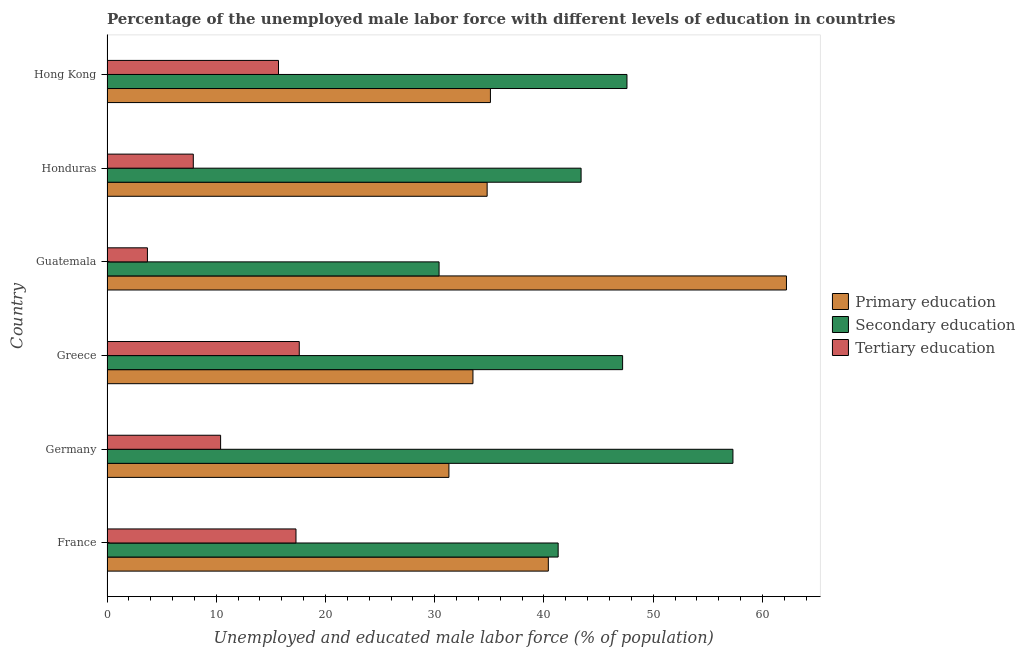How many groups of bars are there?
Give a very brief answer. 6. Are the number of bars per tick equal to the number of legend labels?
Your answer should be compact. Yes. Are the number of bars on each tick of the Y-axis equal?
Your answer should be very brief. Yes. How many bars are there on the 4th tick from the top?
Make the answer very short. 3. How many bars are there on the 3rd tick from the bottom?
Your response must be concise. 3. What is the label of the 6th group of bars from the top?
Give a very brief answer. France. In how many cases, is the number of bars for a given country not equal to the number of legend labels?
Offer a terse response. 0. What is the percentage of male labor force who received tertiary education in Honduras?
Keep it short and to the point. 7.9. Across all countries, what is the maximum percentage of male labor force who received primary education?
Provide a succinct answer. 62.2. Across all countries, what is the minimum percentage of male labor force who received secondary education?
Your answer should be very brief. 30.4. In which country was the percentage of male labor force who received secondary education maximum?
Offer a very short reply. Germany. In which country was the percentage of male labor force who received secondary education minimum?
Your answer should be compact. Guatemala. What is the total percentage of male labor force who received primary education in the graph?
Your response must be concise. 237.3. What is the difference between the percentage of male labor force who received tertiary education in Hong Kong and the percentage of male labor force who received secondary education in Germany?
Your answer should be very brief. -41.6. What is the average percentage of male labor force who received secondary education per country?
Give a very brief answer. 44.53. What is the difference between the percentage of male labor force who received secondary education and percentage of male labor force who received primary education in France?
Your answer should be very brief. 0.9. In how many countries, is the percentage of male labor force who received tertiary education greater than 48 %?
Provide a short and direct response. 0. What is the ratio of the percentage of male labor force who received primary education in France to that in Guatemala?
Your response must be concise. 0.65. Is the percentage of male labor force who received tertiary education in Guatemala less than that in Hong Kong?
Provide a succinct answer. Yes. Is the sum of the percentage of male labor force who received secondary education in Guatemala and Hong Kong greater than the maximum percentage of male labor force who received tertiary education across all countries?
Your response must be concise. Yes. What does the 1st bar from the top in Greece represents?
Provide a short and direct response. Tertiary education. What does the 1st bar from the bottom in Hong Kong represents?
Offer a very short reply. Primary education. Is it the case that in every country, the sum of the percentage of male labor force who received primary education and percentage of male labor force who received secondary education is greater than the percentage of male labor force who received tertiary education?
Offer a very short reply. Yes. Are all the bars in the graph horizontal?
Ensure brevity in your answer.  Yes. How many countries are there in the graph?
Provide a succinct answer. 6. What is the difference between two consecutive major ticks on the X-axis?
Provide a succinct answer. 10. Where does the legend appear in the graph?
Keep it short and to the point. Center right. How many legend labels are there?
Your answer should be compact. 3. What is the title of the graph?
Your answer should be compact. Percentage of the unemployed male labor force with different levels of education in countries. What is the label or title of the X-axis?
Provide a short and direct response. Unemployed and educated male labor force (% of population). What is the label or title of the Y-axis?
Provide a succinct answer. Country. What is the Unemployed and educated male labor force (% of population) in Primary education in France?
Make the answer very short. 40.4. What is the Unemployed and educated male labor force (% of population) of Secondary education in France?
Offer a terse response. 41.3. What is the Unemployed and educated male labor force (% of population) of Tertiary education in France?
Offer a terse response. 17.3. What is the Unemployed and educated male labor force (% of population) in Primary education in Germany?
Offer a very short reply. 31.3. What is the Unemployed and educated male labor force (% of population) in Secondary education in Germany?
Ensure brevity in your answer.  57.3. What is the Unemployed and educated male labor force (% of population) in Tertiary education in Germany?
Your answer should be compact. 10.4. What is the Unemployed and educated male labor force (% of population) of Primary education in Greece?
Offer a very short reply. 33.5. What is the Unemployed and educated male labor force (% of population) in Secondary education in Greece?
Give a very brief answer. 47.2. What is the Unemployed and educated male labor force (% of population) in Tertiary education in Greece?
Offer a terse response. 17.6. What is the Unemployed and educated male labor force (% of population) in Primary education in Guatemala?
Your response must be concise. 62.2. What is the Unemployed and educated male labor force (% of population) of Secondary education in Guatemala?
Make the answer very short. 30.4. What is the Unemployed and educated male labor force (% of population) in Tertiary education in Guatemala?
Your answer should be very brief. 3.7. What is the Unemployed and educated male labor force (% of population) of Primary education in Honduras?
Your answer should be compact. 34.8. What is the Unemployed and educated male labor force (% of population) of Secondary education in Honduras?
Your response must be concise. 43.4. What is the Unemployed and educated male labor force (% of population) of Tertiary education in Honduras?
Make the answer very short. 7.9. What is the Unemployed and educated male labor force (% of population) in Primary education in Hong Kong?
Provide a short and direct response. 35.1. What is the Unemployed and educated male labor force (% of population) of Secondary education in Hong Kong?
Keep it short and to the point. 47.6. What is the Unemployed and educated male labor force (% of population) of Tertiary education in Hong Kong?
Provide a succinct answer. 15.7. Across all countries, what is the maximum Unemployed and educated male labor force (% of population) of Primary education?
Your response must be concise. 62.2. Across all countries, what is the maximum Unemployed and educated male labor force (% of population) in Secondary education?
Your answer should be compact. 57.3. Across all countries, what is the maximum Unemployed and educated male labor force (% of population) in Tertiary education?
Ensure brevity in your answer.  17.6. Across all countries, what is the minimum Unemployed and educated male labor force (% of population) in Primary education?
Your response must be concise. 31.3. Across all countries, what is the minimum Unemployed and educated male labor force (% of population) of Secondary education?
Provide a short and direct response. 30.4. Across all countries, what is the minimum Unemployed and educated male labor force (% of population) of Tertiary education?
Ensure brevity in your answer.  3.7. What is the total Unemployed and educated male labor force (% of population) in Primary education in the graph?
Offer a terse response. 237.3. What is the total Unemployed and educated male labor force (% of population) in Secondary education in the graph?
Offer a very short reply. 267.2. What is the total Unemployed and educated male labor force (% of population) in Tertiary education in the graph?
Your answer should be very brief. 72.6. What is the difference between the Unemployed and educated male labor force (% of population) of Tertiary education in France and that in Germany?
Offer a very short reply. 6.9. What is the difference between the Unemployed and educated male labor force (% of population) of Primary education in France and that in Greece?
Make the answer very short. 6.9. What is the difference between the Unemployed and educated male labor force (% of population) in Secondary education in France and that in Greece?
Your answer should be very brief. -5.9. What is the difference between the Unemployed and educated male labor force (% of population) in Tertiary education in France and that in Greece?
Ensure brevity in your answer.  -0.3. What is the difference between the Unemployed and educated male labor force (% of population) of Primary education in France and that in Guatemala?
Give a very brief answer. -21.8. What is the difference between the Unemployed and educated male labor force (% of population) of Tertiary education in France and that in Guatemala?
Offer a terse response. 13.6. What is the difference between the Unemployed and educated male labor force (% of population) of Primary education in France and that in Honduras?
Your answer should be very brief. 5.6. What is the difference between the Unemployed and educated male labor force (% of population) of Secondary education in France and that in Honduras?
Offer a terse response. -2.1. What is the difference between the Unemployed and educated male labor force (% of population) of Secondary education in France and that in Hong Kong?
Provide a succinct answer. -6.3. What is the difference between the Unemployed and educated male labor force (% of population) in Tertiary education in France and that in Hong Kong?
Give a very brief answer. 1.6. What is the difference between the Unemployed and educated male labor force (% of population) in Primary education in Germany and that in Greece?
Provide a short and direct response. -2.2. What is the difference between the Unemployed and educated male labor force (% of population) in Primary education in Germany and that in Guatemala?
Give a very brief answer. -30.9. What is the difference between the Unemployed and educated male labor force (% of population) in Secondary education in Germany and that in Guatemala?
Ensure brevity in your answer.  26.9. What is the difference between the Unemployed and educated male labor force (% of population) in Secondary education in Germany and that in Honduras?
Provide a succinct answer. 13.9. What is the difference between the Unemployed and educated male labor force (% of population) of Primary education in Germany and that in Hong Kong?
Provide a succinct answer. -3.8. What is the difference between the Unemployed and educated male labor force (% of population) of Secondary education in Germany and that in Hong Kong?
Offer a terse response. 9.7. What is the difference between the Unemployed and educated male labor force (% of population) of Primary education in Greece and that in Guatemala?
Offer a very short reply. -28.7. What is the difference between the Unemployed and educated male labor force (% of population) of Tertiary education in Greece and that in Guatemala?
Give a very brief answer. 13.9. What is the difference between the Unemployed and educated male labor force (% of population) in Primary education in Greece and that in Honduras?
Offer a terse response. -1.3. What is the difference between the Unemployed and educated male labor force (% of population) of Secondary education in Greece and that in Honduras?
Offer a terse response. 3.8. What is the difference between the Unemployed and educated male labor force (% of population) of Tertiary education in Greece and that in Honduras?
Give a very brief answer. 9.7. What is the difference between the Unemployed and educated male labor force (% of population) in Primary education in Greece and that in Hong Kong?
Offer a very short reply. -1.6. What is the difference between the Unemployed and educated male labor force (% of population) in Secondary education in Greece and that in Hong Kong?
Your response must be concise. -0.4. What is the difference between the Unemployed and educated male labor force (% of population) of Primary education in Guatemala and that in Honduras?
Keep it short and to the point. 27.4. What is the difference between the Unemployed and educated male labor force (% of population) in Secondary education in Guatemala and that in Honduras?
Ensure brevity in your answer.  -13. What is the difference between the Unemployed and educated male labor force (% of population) in Primary education in Guatemala and that in Hong Kong?
Give a very brief answer. 27.1. What is the difference between the Unemployed and educated male labor force (% of population) in Secondary education in Guatemala and that in Hong Kong?
Your answer should be compact. -17.2. What is the difference between the Unemployed and educated male labor force (% of population) of Secondary education in Honduras and that in Hong Kong?
Ensure brevity in your answer.  -4.2. What is the difference between the Unemployed and educated male labor force (% of population) of Tertiary education in Honduras and that in Hong Kong?
Offer a terse response. -7.8. What is the difference between the Unemployed and educated male labor force (% of population) in Primary education in France and the Unemployed and educated male labor force (% of population) in Secondary education in Germany?
Make the answer very short. -16.9. What is the difference between the Unemployed and educated male labor force (% of population) in Primary education in France and the Unemployed and educated male labor force (% of population) in Tertiary education in Germany?
Make the answer very short. 30. What is the difference between the Unemployed and educated male labor force (% of population) of Secondary education in France and the Unemployed and educated male labor force (% of population) of Tertiary education in Germany?
Ensure brevity in your answer.  30.9. What is the difference between the Unemployed and educated male labor force (% of population) in Primary education in France and the Unemployed and educated male labor force (% of population) in Secondary education in Greece?
Provide a succinct answer. -6.8. What is the difference between the Unemployed and educated male labor force (% of population) of Primary education in France and the Unemployed and educated male labor force (% of population) of Tertiary education in Greece?
Your answer should be very brief. 22.8. What is the difference between the Unemployed and educated male labor force (% of population) of Secondary education in France and the Unemployed and educated male labor force (% of population) of Tertiary education in Greece?
Ensure brevity in your answer.  23.7. What is the difference between the Unemployed and educated male labor force (% of population) in Primary education in France and the Unemployed and educated male labor force (% of population) in Secondary education in Guatemala?
Your response must be concise. 10. What is the difference between the Unemployed and educated male labor force (% of population) in Primary education in France and the Unemployed and educated male labor force (% of population) in Tertiary education in Guatemala?
Your answer should be very brief. 36.7. What is the difference between the Unemployed and educated male labor force (% of population) in Secondary education in France and the Unemployed and educated male labor force (% of population) in Tertiary education in Guatemala?
Ensure brevity in your answer.  37.6. What is the difference between the Unemployed and educated male labor force (% of population) of Primary education in France and the Unemployed and educated male labor force (% of population) of Tertiary education in Honduras?
Your answer should be compact. 32.5. What is the difference between the Unemployed and educated male labor force (% of population) of Secondary education in France and the Unemployed and educated male labor force (% of population) of Tertiary education in Honduras?
Your response must be concise. 33.4. What is the difference between the Unemployed and educated male labor force (% of population) of Primary education in France and the Unemployed and educated male labor force (% of population) of Secondary education in Hong Kong?
Make the answer very short. -7.2. What is the difference between the Unemployed and educated male labor force (% of population) in Primary education in France and the Unemployed and educated male labor force (% of population) in Tertiary education in Hong Kong?
Ensure brevity in your answer.  24.7. What is the difference between the Unemployed and educated male labor force (% of population) of Secondary education in France and the Unemployed and educated male labor force (% of population) of Tertiary education in Hong Kong?
Make the answer very short. 25.6. What is the difference between the Unemployed and educated male labor force (% of population) in Primary education in Germany and the Unemployed and educated male labor force (% of population) in Secondary education in Greece?
Provide a short and direct response. -15.9. What is the difference between the Unemployed and educated male labor force (% of population) in Primary education in Germany and the Unemployed and educated male labor force (% of population) in Tertiary education in Greece?
Provide a short and direct response. 13.7. What is the difference between the Unemployed and educated male labor force (% of population) in Secondary education in Germany and the Unemployed and educated male labor force (% of population) in Tertiary education in Greece?
Your answer should be very brief. 39.7. What is the difference between the Unemployed and educated male labor force (% of population) in Primary education in Germany and the Unemployed and educated male labor force (% of population) in Secondary education in Guatemala?
Your answer should be compact. 0.9. What is the difference between the Unemployed and educated male labor force (% of population) of Primary education in Germany and the Unemployed and educated male labor force (% of population) of Tertiary education in Guatemala?
Offer a very short reply. 27.6. What is the difference between the Unemployed and educated male labor force (% of population) of Secondary education in Germany and the Unemployed and educated male labor force (% of population) of Tertiary education in Guatemala?
Keep it short and to the point. 53.6. What is the difference between the Unemployed and educated male labor force (% of population) of Primary education in Germany and the Unemployed and educated male labor force (% of population) of Secondary education in Honduras?
Offer a very short reply. -12.1. What is the difference between the Unemployed and educated male labor force (% of population) of Primary education in Germany and the Unemployed and educated male labor force (% of population) of Tertiary education in Honduras?
Your response must be concise. 23.4. What is the difference between the Unemployed and educated male labor force (% of population) in Secondary education in Germany and the Unemployed and educated male labor force (% of population) in Tertiary education in Honduras?
Offer a very short reply. 49.4. What is the difference between the Unemployed and educated male labor force (% of population) in Primary education in Germany and the Unemployed and educated male labor force (% of population) in Secondary education in Hong Kong?
Your answer should be very brief. -16.3. What is the difference between the Unemployed and educated male labor force (% of population) in Secondary education in Germany and the Unemployed and educated male labor force (% of population) in Tertiary education in Hong Kong?
Provide a short and direct response. 41.6. What is the difference between the Unemployed and educated male labor force (% of population) in Primary education in Greece and the Unemployed and educated male labor force (% of population) in Secondary education in Guatemala?
Provide a succinct answer. 3.1. What is the difference between the Unemployed and educated male labor force (% of population) of Primary education in Greece and the Unemployed and educated male labor force (% of population) of Tertiary education in Guatemala?
Offer a very short reply. 29.8. What is the difference between the Unemployed and educated male labor force (% of population) of Secondary education in Greece and the Unemployed and educated male labor force (% of population) of Tertiary education in Guatemala?
Make the answer very short. 43.5. What is the difference between the Unemployed and educated male labor force (% of population) of Primary education in Greece and the Unemployed and educated male labor force (% of population) of Secondary education in Honduras?
Provide a short and direct response. -9.9. What is the difference between the Unemployed and educated male labor force (% of population) of Primary education in Greece and the Unemployed and educated male labor force (% of population) of Tertiary education in Honduras?
Provide a succinct answer. 25.6. What is the difference between the Unemployed and educated male labor force (% of population) of Secondary education in Greece and the Unemployed and educated male labor force (% of population) of Tertiary education in Honduras?
Your answer should be very brief. 39.3. What is the difference between the Unemployed and educated male labor force (% of population) of Primary education in Greece and the Unemployed and educated male labor force (% of population) of Secondary education in Hong Kong?
Your response must be concise. -14.1. What is the difference between the Unemployed and educated male labor force (% of population) in Secondary education in Greece and the Unemployed and educated male labor force (% of population) in Tertiary education in Hong Kong?
Give a very brief answer. 31.5. What is the difference between the Unemployed and educated male labor force (% of population) of Primary education in Guatemala and the Unemployed and educated male labor force (% of population) of Secondary education in Honduras?
Provide a succinct answer. 18.8. What is the difference between the Unemployed and educated male labor force (% of population) of Primary education in Guatemala and the Unemployed and educated male labor force (% of population) of Tertiary education in Honduras?
Keep it short and to the point. 54.3. What is the difference between the Unemployed and educated male labor force (% of population) in Secondary education in Guatemala and the Unemployed and educated male labor force (% of population) in Tertiary education in Honduras?
Provide a succinct answer. 22.5. What is the difference between the Unemployed and educated male labor force (% of population) of Primary education in Guatemala and the Unemployed and educated male labor force (% of population) of Secondary education in Hong Kong?
Provide a succinct answer. 14.6. What is the difference between the Unemployed and educated male labor force (% of population) in Primary education in Guatemala and the Unemployed and educated male labor force (% of population) in Tertiary education in Hong Kong?
Keep it short and to the point. 46.5. What is the difference between the Unemployed and educated male labor force (% of population) of Secondary education in Guatemala and the Unemployed and educated male labor force (% of population) of Tertiary education in Hong Kong?
Offer a very short reply. 14.7. What is the difference between the Unemployed and educated male labor force (% of population) of Secondary education in Honduras and the Unemployed and educated male labor force (% of population) of Tertiary education in Hong Kong?
Offer a terse response. 27.7. What is the average Unemployed and educated male labor force (% of population) of Primary education per country?
Your answer should be compact. 39.55. What is the average Unemployed and educated male labor force (% of population) in Secondary education per country?
Keep it short and to the point. 44.53. What is the difference between the Unemployed and educated male labor force (% of population) of Primary education and Unemployed and educated male labor force (% of population) of Tertiary education in France?
Your answer should be very brief. 23.1. What is the difference between the Unemployed and educated male labor force (% of population) in Secondary education and Unemployed and educated male labor force (% of population) in Tertiary education in France?
Your response must be concise. 24. What is the difference between the Unemployed and educated male labor force (% of population) in Primary education and Unemployed and educated male labor force (% of population) in Secondary education in Germany?
Your response must be concise. -26. What is the difference between the Unemployed and educated male labor force (% of population) in Primary education and Unemployed and educated male labor force (% of population) in Tertiary education in Germany?
Provide a succinct answer. 20.9. What is the difference between the Unemployed and educated male labor force (% of population) in Secondary education and Unemployed and educated male labor force (% of population) in Tertiary education in Germany?
Give a very brief answer. 46.9. What is the difference between the Unemployed and educated male labor force (% of population) in Primary education and Unemployed and educated male labor force (% of population) in Secondary education in Greece?
Your response must be concise. -13.7. What is the difference between the Unemployed and educated male labor force (% of population) in Secondary education and Unemployed and educated male labor force (% of population) in Tertiary education in Greece?
Keep it short and to the point. 29.6. What is the difference between the Unemployed and educated male labor force (% of population) in Primary education and Unemployed and educated male labor force (% of population) in Secondary education in Guatemala?
Offer a terse response. 31.8. What is the difference between the Unemployed and educated male labor force (% of population) of Primary education and Unemployed and educated male labor force (% of population) of Tertiary education in Guatemala?
Your response must be concise. 58.5. What is the difference between the Unemployed and educated male labor force (% of population) of Secondary education and Unemployed and educated male labor force (% of population) of Tertiary education in Guatemala?
Give a very brief answer. 26.7. What is the difference between the Unemployed and educated male labor force (% of population) in Primary education and Unemployed and educated male labor force (% of population) in Tertiary education in Honduras?
Offer a terse response. 26.9. What is the difference between the Unemployed and educated male labor force (% of population) in Secondary education and Unemployed and educated male labor force (% of population) in Tertiary education in Honduras?
Keep it short and to the point. 35.5. What is the difference between the Unemployed and educated male labor force (% of population) of Primary education and Unemployed and educated male labor force (% of population) of Tertiary education in Hong Kong?
Offer a terse response. 19.4. What is the difference between the Unemployed and educated male labor force (% of population) in Secondary education and Unemployed and educated male labor force (% of population) in Tertiary education in Hong Kong?
Your answer should be compact. 31.9. What is the ratio of the Unemployed and educated male labor force (% of population) of Primary education in France to that in Germany?
Provide a succinct answer. 1.29. What is the ratio of the Unemployed and educated male labor force (% of population) of Secondary education in France to that in Germany?
Your answer should be compact. 0.72. What is the ratio of the Unemployed and educated male labor force (% of population) of Tertiary education in France to that in Germany?
Ensure brevity in your answer.  1.66. What is the ratio of the Unemployed and educated male labor force (% of population) of Primary education in France to that in Greece?
Make the answer very short. 1.21. What is the ratio of the Unemployed and educated male labor force (% of population) of Primary education in France to that in Guatemala?
Ensure brevity in your answer.  0.65. What is the ratio of the Unemployed and educated male labor force (% of population) in Secondary education in France to that in Guatemala?
Offer a very short reply. 1.36. What is the ratio of the Unemployed and educated male labor force (% of population) in Tertiary education in France to that in Guatemala?
Make the answer very short. 4.68. What is the ratio of the Unemployed and educated male labor force (% of population) of Primary education in France to that in Honduras?
Make the answer very short. 1.16. What is the ratio of the Unemployed and educated male labor force (% of population) of Secondary education in France to that in Honduras?
Offer a very short reply. 0.95. What is the ratio of the Unemployed and educated male labor force (% of population) of Tertiary education in France to that in Honduras?
Your response must be concise. 2.19. What is the ratio of the Unemployed and educated male labor force (% of population) of Primary education in France to that in Hong Kong?
Provide a short and direct response. 1.15. What is the ratio of the Unemployed and educated male labor force (% of population) in Secondary education in France to that in Hong Kong?
Your answer should be compact. 0.87. What is the ratio of the Unemployed and educated male labor force (% of population) in Tertiary education in France to that in Hong Kong?
Provide a short and direct response. 1.1. What is the ratio of the Unemployed and educated male labor force (% of population) of Primary education in Germany to that in Greece?
Keep it short and to the point. 0.93. What is the ratio of the Unemployed and educated male labor force (% of population) in Secondary education in Germany to that in Greece?
Make the answer very short. 1.21. What is the ratio of the Unemployed and educated male labor force (% of population) in Tertiary education in Germany to that in Greece?
Make the answer very short. 0.59. What is the ratio of the Unemployed and educated male labor force (% of population) in Primary education in Germany to that in Guatemala?
Provide a succinct answer. 0.5. What is the ratio of the Unemployed and educated male labor force (% of population) of Secondary education in Germany to that in Guatemala?
Keep it short and to the point. 1.88. What is the ratio of the Unemployed and educated male labor force (% of population) in Tertiary education in Germany to that in Guatemala?
Your answer should be compact. 2.81. What is the ratio of the Unemployed and educated male labor force (% of population) of Primary education in Germany to that in Honduras?
Your answer should be compact. 0.9. What is the ratio of the Unemployed and educated male labor force (% of population) in Secondary education in Germany to that in Honduras?
Offer a very short reply. 1.32. What is the ratio of the Unemployed and educated male labor force (% of population) in Tertiary education in Germany to that in Honduras?
Provide a succinct answer. 1.32. What is the ratio of the Unemployed and educated male labor force (% of population) of Primary education in Germany to that in Hong Kong?
Offer a terse response. 0.89. What is the ratio of the Unemployed and educated male labor force (% of population) in Secondary education in Germany to that in Hong Kong?
Make the answer very short. 1.2. What is the ratio of the Unemployed and educated male labor force (% of population) of Tertiary education in Germany to that in Hong Kong?
Make the answer very short. 0.66. What is the ratio of the Unemployed and educated male labor force (% of population) of Primary education in Greece to that in Guatemala?
Give a very brief answer. 0.54. What is the ratio of the Unemployed and educated male labor force (% of population) in Secondary education in Greece to that in Guatemala?
Ensure brevity in your answer.  1.55. What is the ratio of the Unemployed and educated male labor force (% of population) of Tertiary education in Greece to that in Guatemala?
Your response must be concise. 4.76. What is the ratio of the Unemployed and educated male labor force (% of population) in Primary education in Greece to that in Honduras?
Ensure brevity in your answer.  0.96. What is the ratio of the Unemployed and educated male labor force (% of population) of Secondary education in Greece to that in Honduras?
Give a very brief answer. 1.09. What is the ratio of the Unemployed and educated male labor force (% of population) in Tertiary education in Greece to that in Honduras?
Your answer should be compact. 2.23. What is the ratio of the Unemployed and educated male labor force (% of population) in Primary education in Greece to that in Hong Kong?
Provide a short and direct response. 0.95. What is the ratio of the Unemployed and educated male labor force (% of population) of Tertiary education in Greece to that in Hong Kong?
Offer a terse response. 1.12. What is the ratio of the Unemployed and educated male labor force (% of population) in Primary education in Guatemala to that in Honduras?
Your response must be concise. 1.79. What is the ratio of the Unemployed and educated male labor force (% of population) of Secondary education in Guatemala to that in Honduras?
Keep it short and to the point. 0.7. What is the ratio of the Unemployed and educated male labor force (% of population) of Tertiary education in Guatemala to that in Honduras?
Your response must be concise. 0.47. What is the ratio of the Unemployed and educated male labor force (% of population) in Primary education in Guatemala to that in Hong Kong?
Your response must be concise. 1.77. What is the ratio of the Unemployed and educated male labor force (% of population) of Secondary education in Guatemala to that in Hong Kong?
Offer a terse response. 0.64. What is the ratio of the Unemployed and educated male labor force (% of population) of Tertiary education in Guatemala to that in Hong Kong?
Your answer should be compact. 0.24. What is the ratio of the Unemployed and educated male labor force (% of population) in Primary education in Honduras to that in Hong Kong?
Your answer should be compact. 0.99. What is the ratio of the Unemployed and educated male labor force (% of population) in Secondary education in Honduras to that in Hong Kong?
Give a very brief answer. 0.91. What is the ratio of the Unemployed and educated male labor force (% of population) in Tertiary education in Honduras to that in Hong Kong?
Your answer should be very brief. 0.5. What is the difference between the highest and the second highest Unemployed and educated male labor force (% of population) in Primary education?
Make the answer very short. 21.8. What is the difference between the highest and the second highest Unemployed and educated male labor force (% of population) of Secondary education?
Make the answer very short. 9.7. What is the difference between the highest and the second highest Unemployed and educated male labor force (% of population) of Tertiary education?
Make the answer very short. 0.3. What is the difference between the highest and the lowest Unemployed and educated male labor force (% of population) of Primary education?
Provide a short and direct response. 30.9. What is the difference between the highest and the lowest Unemployed and educated male labor force (% of population) in Secondary education?
Give a very brief answer. 26.9. What is the difference between the highest and the lowest Unemployed and educated male labor force (% of population) in Tertiary education?
Offer a terse response. 13.9. 